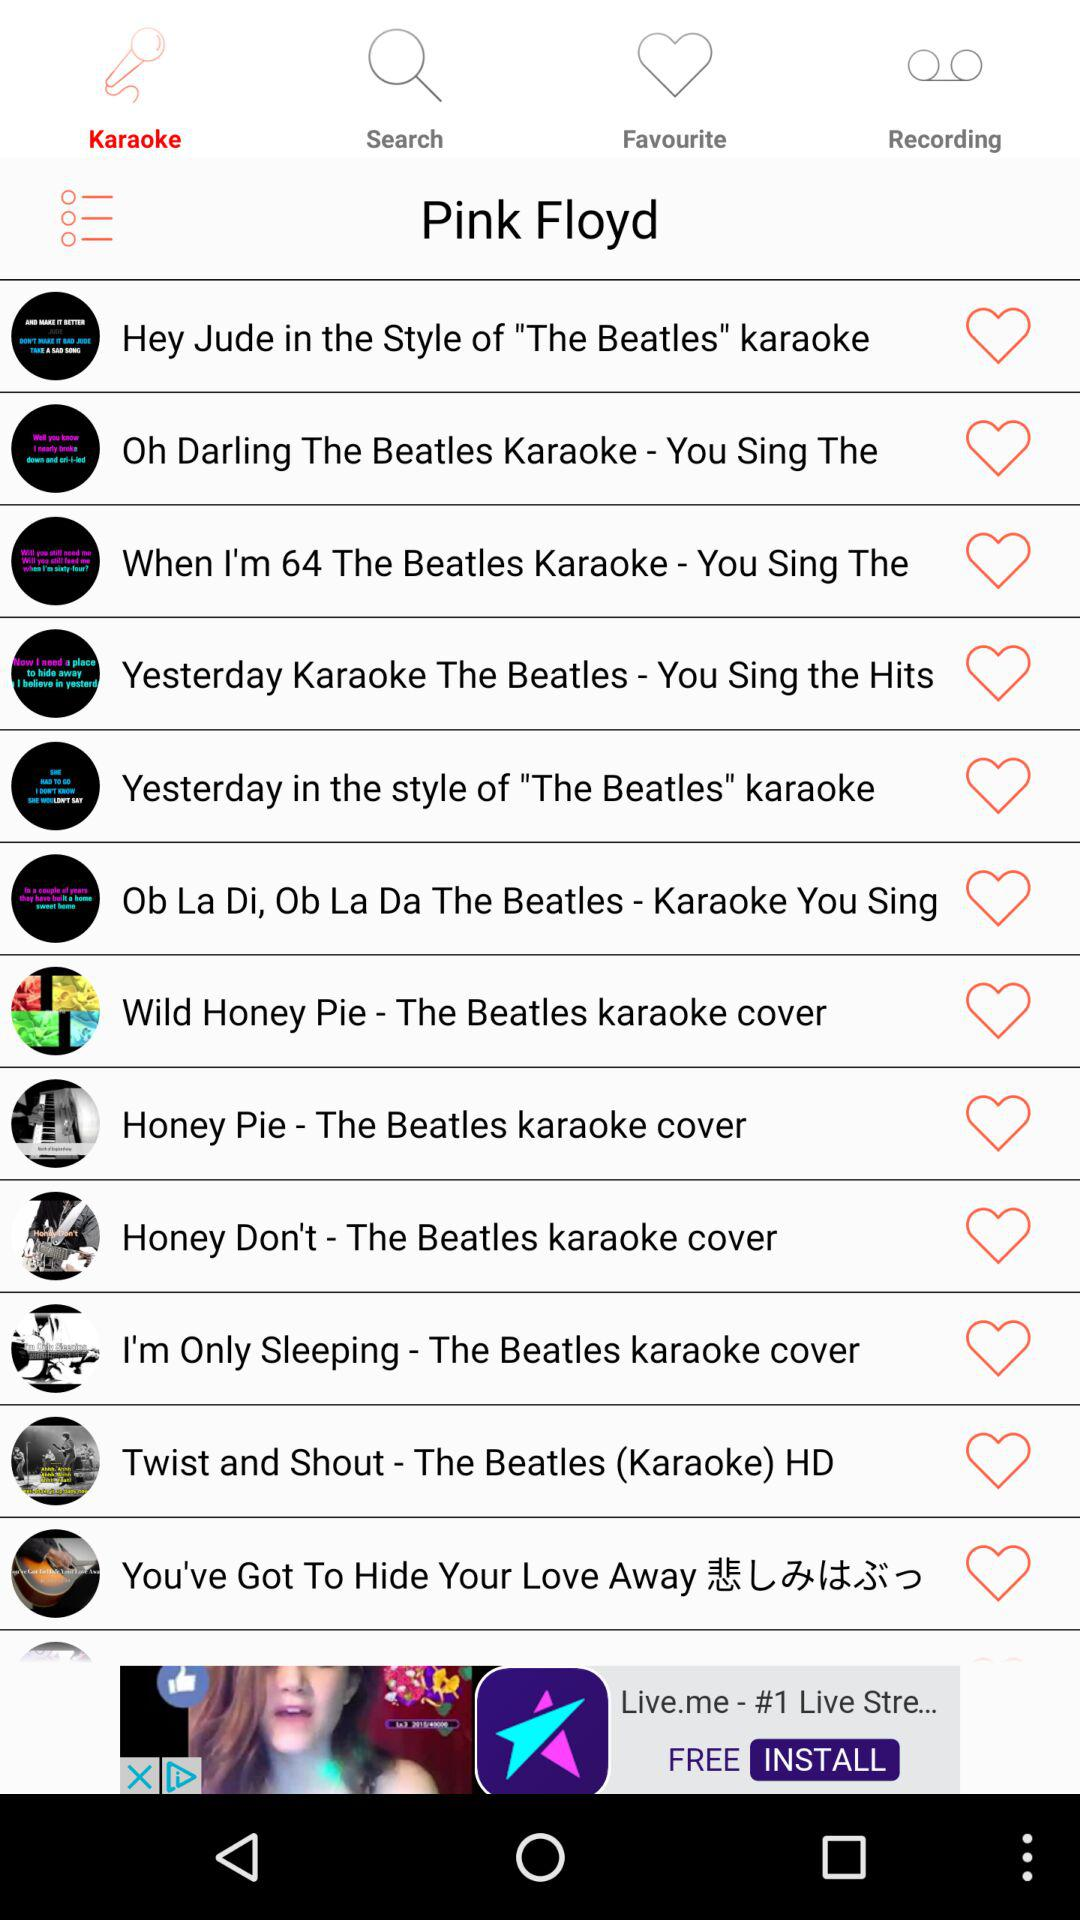Which tab is selected? The selected tab is "Karaoke". 